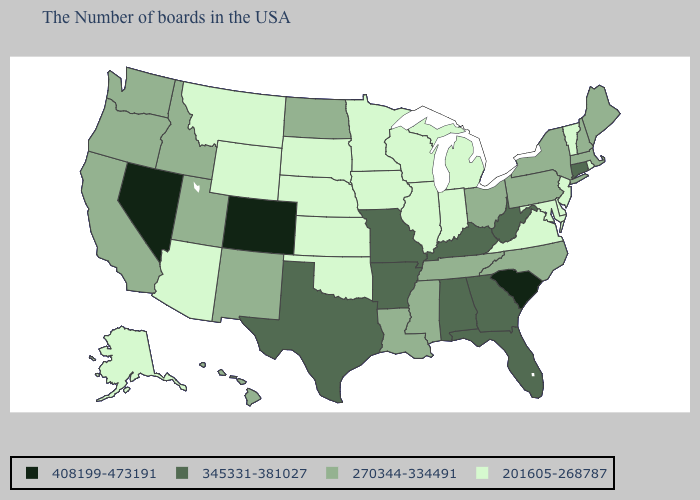Among the states that border Illinois , which have the lowest value?
Quick response, please. Indiana, Wisconsin, Iowa. Does South Carolina have the lowest value in the USA?
Give a very brief answer. No. Which states have the lowest value in the USA?
Answer briefly. Rhode Island, Vermont, New Jersey, Delaware, Maryland, Virginia, Michigan, Indiana, Wisconsin, Illinois, Minnesota, Iowa, Kansas, Nebraska, Oklahoma, South Dakota, Wyoming, Montana, Arizona, Alaska. What is the value of Florida?
Answer briefly. 345331-381027. Does Idaho have the lowest value in the USA?
Answer briefly. No. What is the lowest value in the MidWest?
Answer briefly. 201605-268787. Name the states that have a value in the range 408199-473191?
Keep it brief. South Carolina, Colorado, Nevada. Name the states that have a value in the range 201605-268787?
Concise answer only. Rhode Island, Vermont, New Jersey, Delaware, Maryland, Virginia, Michigan, Indiana, Wisconsin, Illinois, Minnesota, Iowa, Kansas, Nebraska, Oklahoma, South Dakota, Wyoming, Montana, Arizona, Alaska. Among the states that border Minnesota , does Iowa have the highest value?
Write a very short answer. No. What is the lowest value in states that border Nevada?
Write a very short answer. 201605-268787. What is the value of Texas?
Answer briefly. 345331-381027. Does the map have missing data?
Write a very short answer. No. What is the highest value in the USA?
Answer briefly. 408199-473191. Which states have the lowest value in the Northeast?
Be succinct. Rhode Island, Vermont, New Jersey. Name the states that have a value in the range 408199-473191?
Be succinct. South Carolina, Colorado, Nevada. 